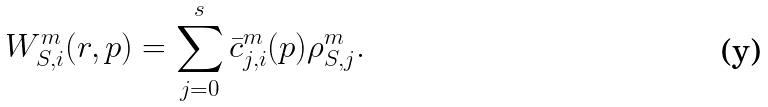<formula> <loc_0><loc_0><loc_500><loc_500>W _ { S , i } ^ { m } ( r , p ) = \sum _ { j = 0 } ^ { s } \bar { c } _ { j , i } ^ { m } ( p ) \rho _ { S , j } ^ { m } .</formula> 